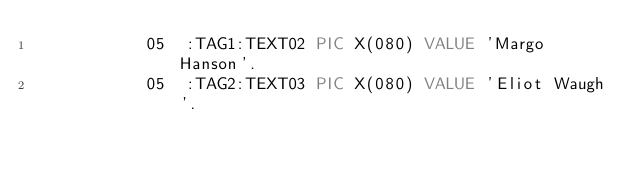Convert code to text. <code><loc_0><loc_0><loc_500><loc_500><_COBOL_>           05  :TAG1:TEXT02 PIC X(080) VALUE 'Margo Hanson'.
           05  :TAG2:TEXT03 PIC X(080) VALUE 'Eliot Waugh'.
</code> 